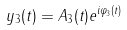Convert formula to latex. <formula><loc_0><loc_0><loc_500><loc_500>y _ { 3 } ( t ) = A _ { 3 } ( t ) e ^ { i \varphi _ { 3 } ( t ) }</formula> 